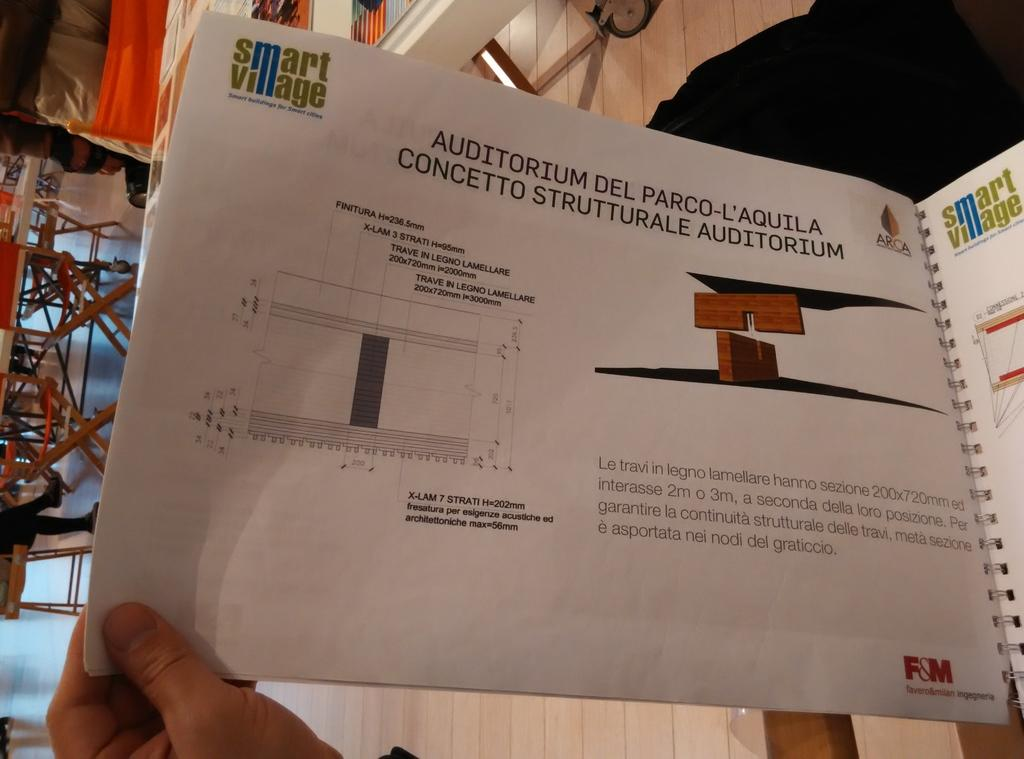<image>
Present a compact description of the photo's key features. A page in a Smart Village booklet titled Auditorium Del Parco-L'Aquila Concetto Strutturale Auditorium. 